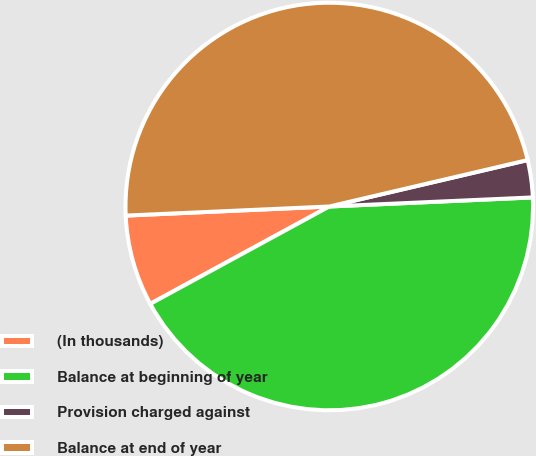<chart> <loc_0><loc_0><loc_500><loc_500><pie_chart><fcel>(In thousands)<fcel>Balance at beginning of year<fcel>Provision charged against<fcel>Balance at end of year<nl><fcel>7.22%<fcel>42.78%<fcel>2.95%<fcel>47.05%<nl></chart> 